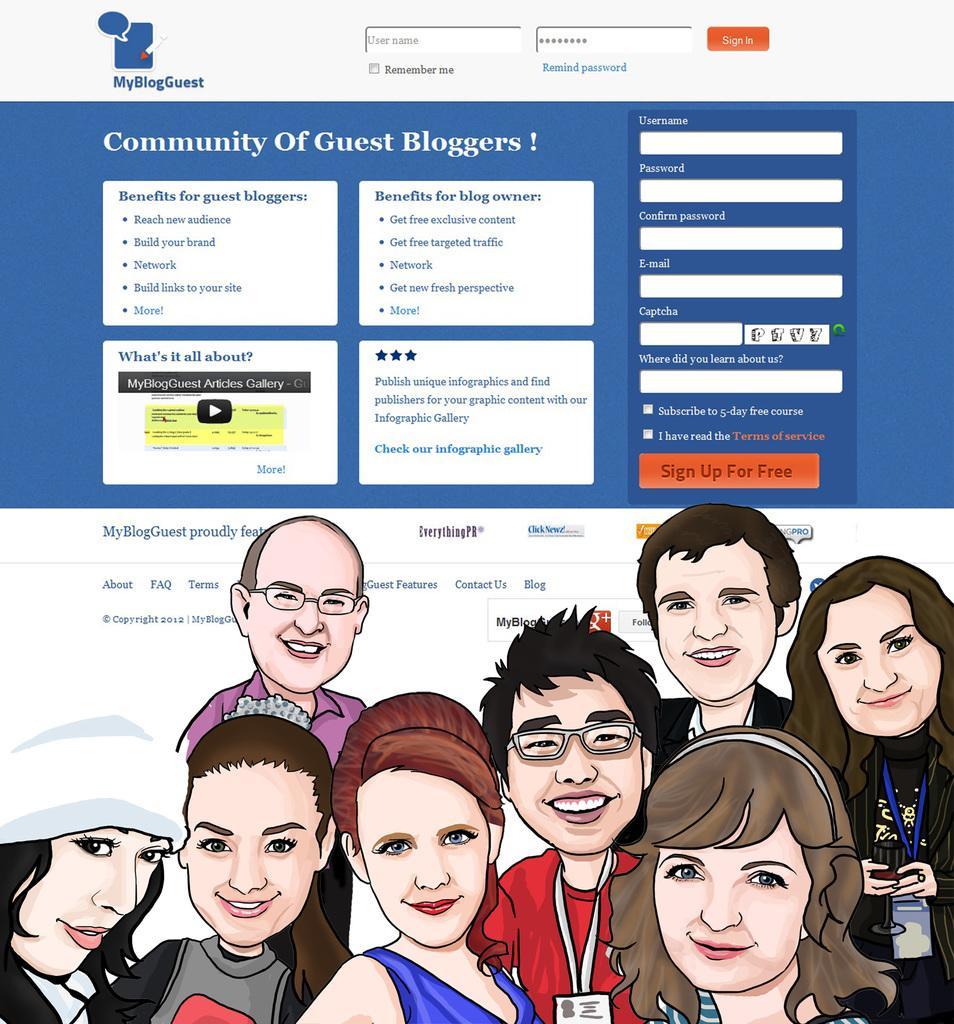Can you describe this image briefly? At the bottom of the picture, we see the illustrations of the men and the women. All of them are smiling and they are posing for the photo. At the top, we see some text printed. In the background, it is in white and blue color. This might be an edited image. 